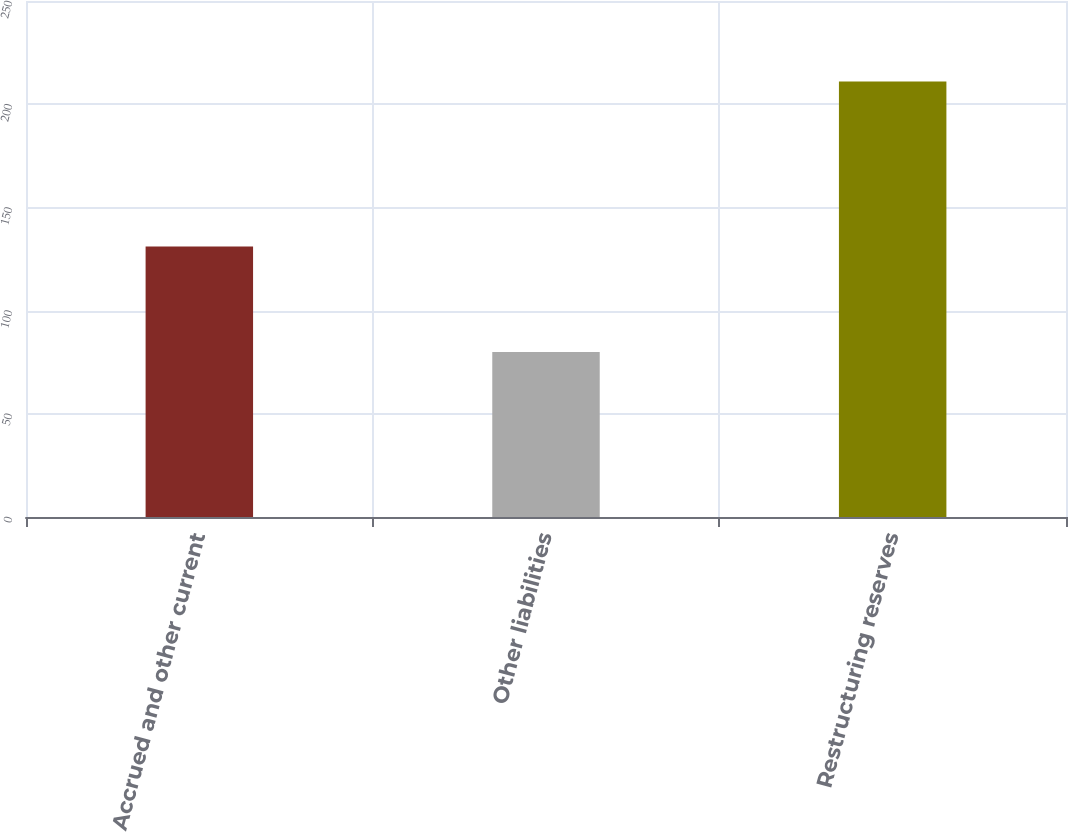Convert chart. <chart><loc_0><loc_0><loc_500><loc_500><bar_chart><fcel>Accrued and other current<fcel>Other liabilities<fcel>Restructuring reserves<nl><fcel>131<fcel>80<fcel>211<nl></chart> 